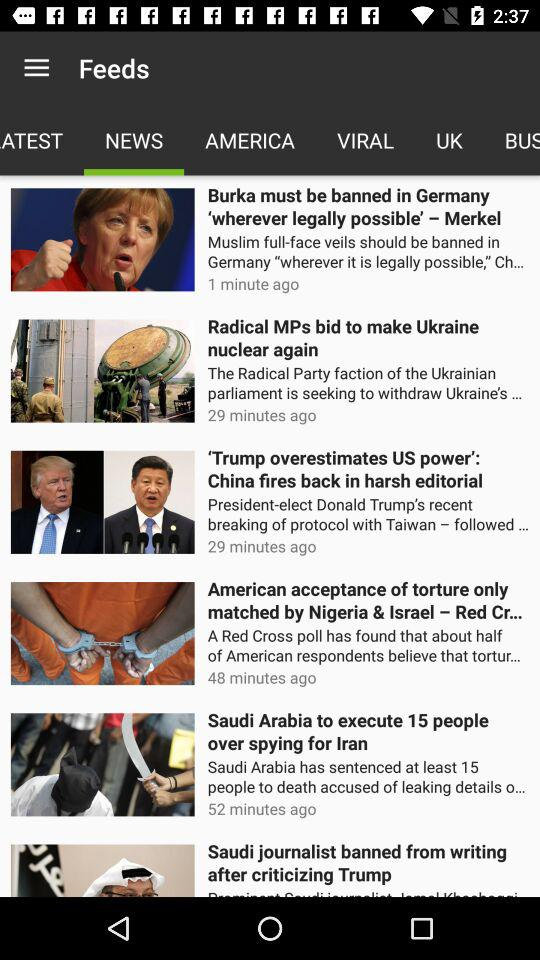How many stories are on this page?
Answer the question using a single word or phrase. 6 